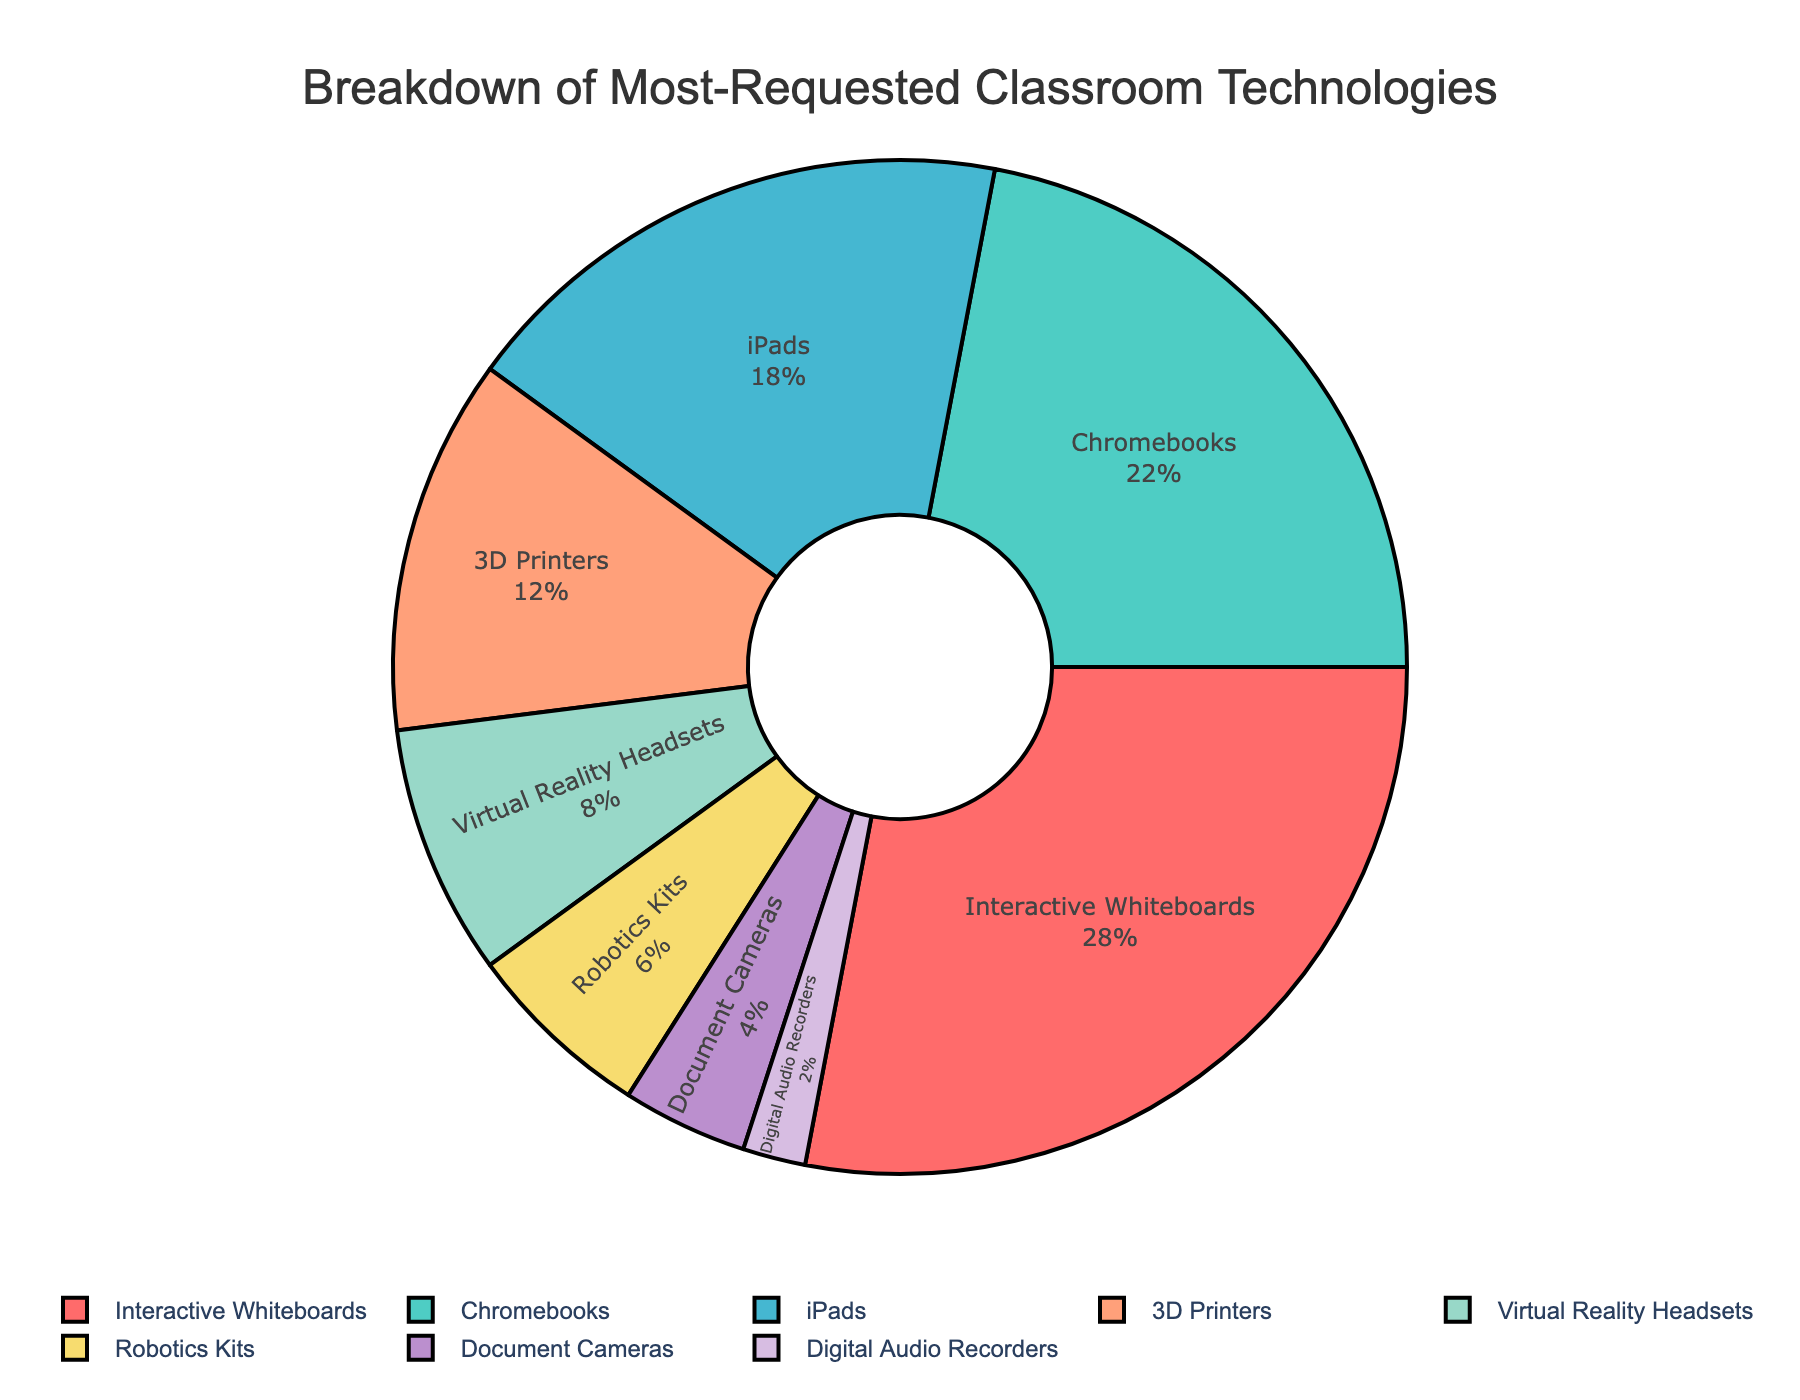What percentage of requests were for Chromebooks? Chromebooks are marked as 22% in the pie chart.
Answer: 22% How many percentage points more requests are there for Interactive Whiteboards than for iPads? Interactive Whiteboards account for 28% and iPads for 18%. The difference is 28% - 18% = 10%.
Answer: 10% Which technology had the least number of requests and what percentage was it? Digital Audio Recorders had the least requests at 2%.
Answer: Digital Audio Recorders, 2% What is the combined percentage of requests for 3D Printers and Virtual Reality Headsets? 3D Printers are 12% and Virtual Reality Headsets are 8%. The combined percentage is 12% + 8% = 20%.
Answer: 20% Are there more requests for Chromebooks or iPads, and by what percentage difference? Chromebooks have 22% and iPads have 18%. The difference is 22% - 18% = 4%.
Answer: Chromebooks, 4% What is the total percentage of requests for technologies other than Interactive Whiteboards and Chromebooks? Interactive Whiteboards and Chromebooks sum up to 28% + 22% = 50%. The remaining percentage is 100% - 50% = 50%.
Answer: 50% What percentage of requests do Robotics Kits and Document Cameras together represent? Robotics Kits are 6% and Document Cameras are 4%. Together, they represent 6% + 4% = 10%.
Answer: 10% How many percentage points more requests are there for 3D Printers compared to Robotics Kits? 3D Printers have 12% while Robotics Kits have 6%. The difference is 12% - 6% = 6%.
Answer: 6% Which technology received twice as many requests as Robotics Kits? Robotics Kits are 6%, so twice that is 6% x 2 = 12%, which corresponds to 3D Printers.
Answer: 3D Printers 